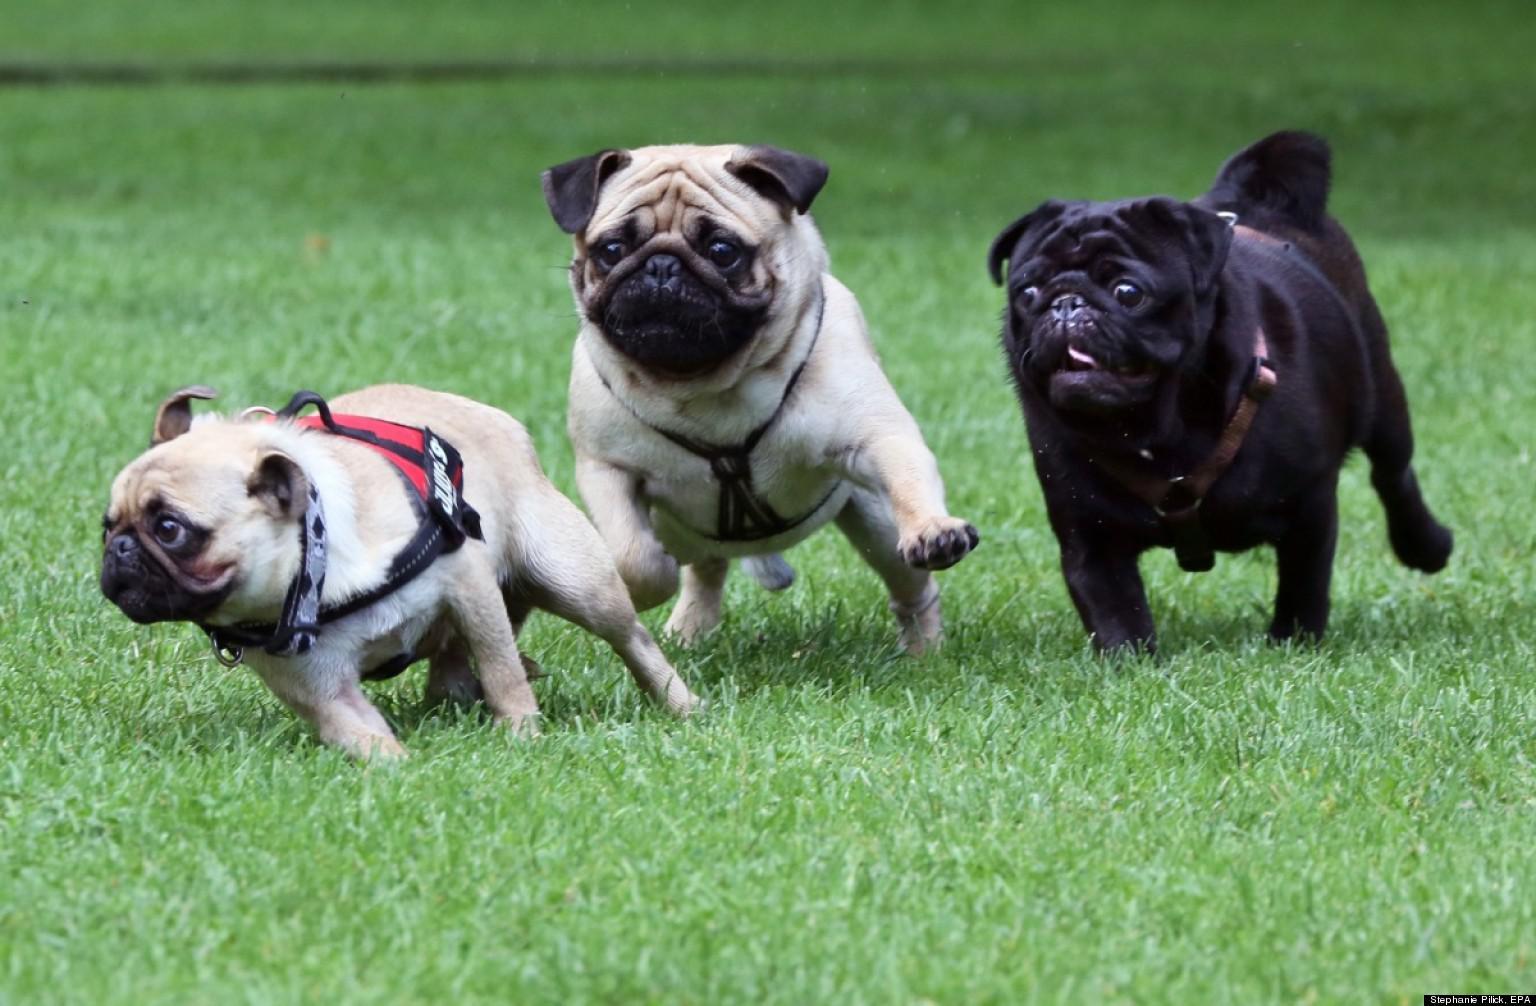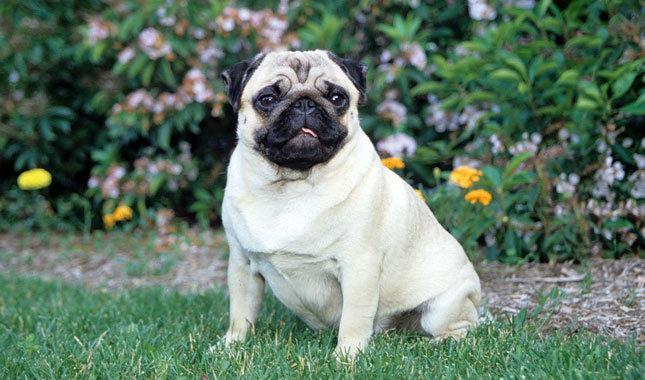The first image is the image on the left, the second image is the image on the right. Analyze the images presented: Is the assertion "The right image contains three pug dogs." valid? Answer yes or no. No. 